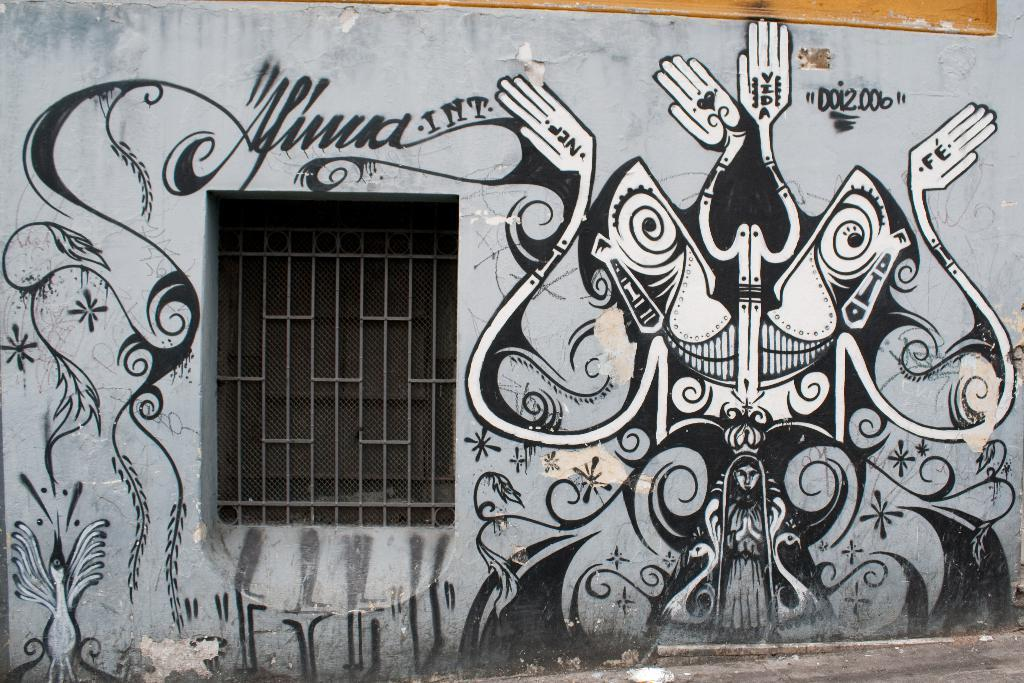What is present on the wall in the image? There is a window and a painting on the wall in the image. Can you describe the painting? The painting is in black and white color. What is the purpose of the window on the wall? The window allows light to enter the room and provides a view of the outside. Where can you find the store selling crayons in the image? There is no store or crayons present in the image. What is the attempt made by the painting in the image? The painting is not making any attempt, as it is an inanimate object. 